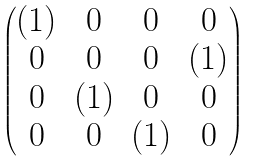Convert formula to latex. <formula><loc_0><loc_0><loc_500><loc_500>\begin{pmatrix} ( 1 ) & 0 & 0 & 0 \\ 0 & 0 & 0 & ( 1 ) \\ 0 & ( 1 ) & 0 & 0 \\ 0 & 0 & ( 1 ) & 0 \end{pmatrix}</formula> 